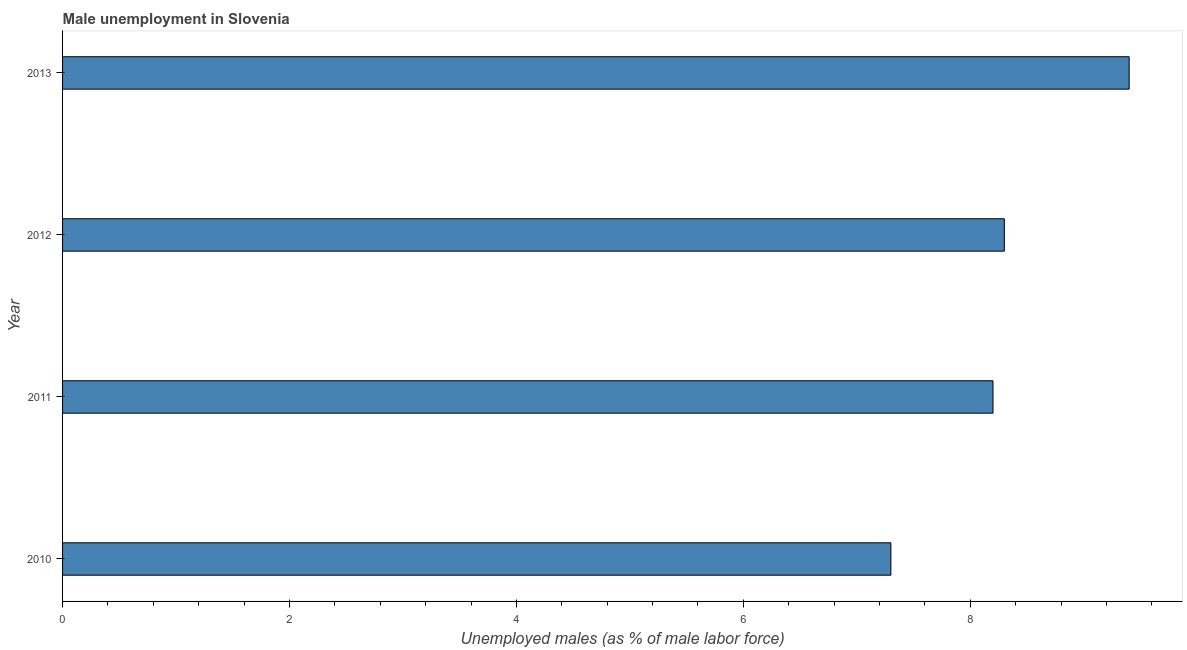What is the title of the graph?
Give a very brief answer. Male unemployment in Slovenia. What is the label or title of the X-axis?
Offer a terse response. Unemployed males (as % of male labor force). What is the label or title of the Y-axis?
Provide a short and direct response. Year. What is the unemployed males population in 2013?
Keep it short and to the point. 9.4. Across all years, what is the maximum unemployed males population?
Provide a short and direct response. 9.4. Across all years, what is the minimum unemployed males population?
Offer a very short reply. 7.3. In which year was the unemployed males population minimum?
Give a very brief answer. 2010. What is the sum of the unemployed males population?
Offer a terse response. 33.2. What is the median unemployed males population?
Ensure brevity in your answer.  8.25. In how many years, is the unemployed males population greater than 1.6 %?
Make the answer very short. 4. Do a majority of the years between 2011 and 2010 (inclusive) have unemployed males population greater than 1.2 %?
Ensure brevity in your answer.  No. What is the ratio of the unemployed males population in 2011 to that in 2013?
Provide a succinct answer. 0.87. Is the difference between the unemployed males population in 2011 and 2013 greater than the difference between any two years?
Offer a very short reply. No. What is the difference between the highest and the second highest unemployed males population?
Your answer should be very brief. 1.1. Is the sum of the unemployed males population in 2010 and 2012 greater than the maximum unemployed males population across all years?
Give a very brief answer. Yes. How many bars are there?
Ensure brevity in your answer.  4. Are all the bars in the graph horizontal?
Keep it short and to the point. Yes. What is the difference between two consecutive major ticks on the X-axis?
Give a very brief answer. 2. What is the Unemployed males (as % of male labor force) in 2010?
Keep it short and to the point. 7.3. What is the Unemployed males (as % of male labor force) of 2011?
Your response must be concise. 8.2. What is the Unemployed males (as % of male labor force) in 2012?
Give a very brief answer. 8.3. What is the Unemployed males (as % of male labor force) in 2013?
Your answer should be very brief. 9.4. What is the difference between the Unemployed males (as % of male labor force) in 2011 and 2013?
Your response must be concise. -1.2. What is the ratio of the Unemployed males (as % of male labor force) in 2010 to that in 2011?
Your response must be concise. 0.89. What is the ratio of the Unemployed males (as % of male labor force) in 2010 to that in 2012?
Your response must be concise. 0.88. What is the ratio of the Unemployed males (as % of male labor force) in 2010 to that in 2013?
Your answer should be compact. 0.78. What is the ratio of the Unemployed males (as % of male labor force) in 2011 to that in 2013?
Provide a short and direct response. 0.87. What is the ratio of the Unemployed males (as % of male labor force) in 2012 to that in 2013?
Your answer should be very brief. 0.88. 